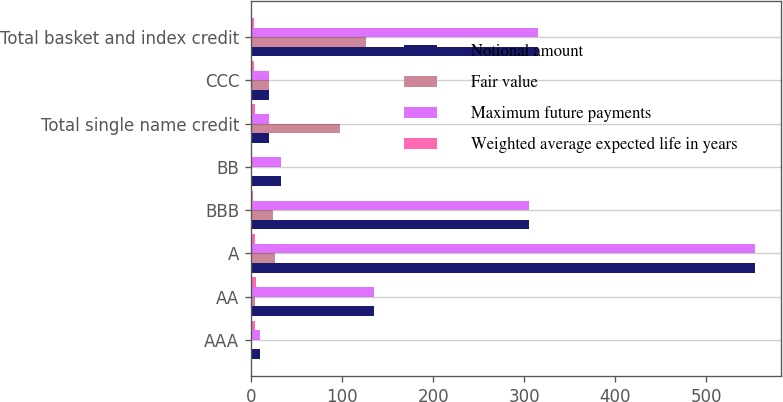Convert chart to OTSL. <chart><loc_0><loc_0><loc_500><loc_500><stacked_bar_chart><ecel><fcel>AAA<fcel>AA<fcel>A<fcel>BBB<fcel>BB<fcel>Total single name credit<fcel>CCC<fcel>Total basket and index credit<nl><fcel>Notional amount<fcel>10<fcel>135<fcel>554<fcel>305<fcel>33<fcel>20<fcel>20<fcel>315<nl><fcel>Fair value<fcel>1<fcel>4.6<fcel>25.8<fcel>24.4<fcel>1.4<fcel>98.2<fcel>20<fcel>125.9<nl><fcel>Maximum future payments<fcel>10<fcel>135<fcel>554<fcel>305<fcel>33<fcel>20<fcel>20<fcel>315<nl><fcel>Weighted average expected life in years<fcel>4.5<fcel>5.4<fcel>4.8<fcel>2.7<fcel>0.5<fcel>4.4<fcel>3<fcel>3<nl></chart> 